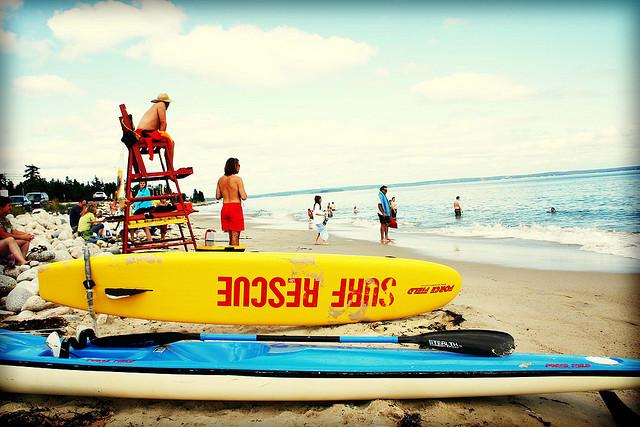What does the yellow board say?
Quick response, please. Surf rescue. Is there a lifeguard on duty?
Be succinct. Yes. What is the blue item in the foreground?
Keep it brief. Kayak. Is this man dressed to go surfing?
Keep it brief. Yes. 